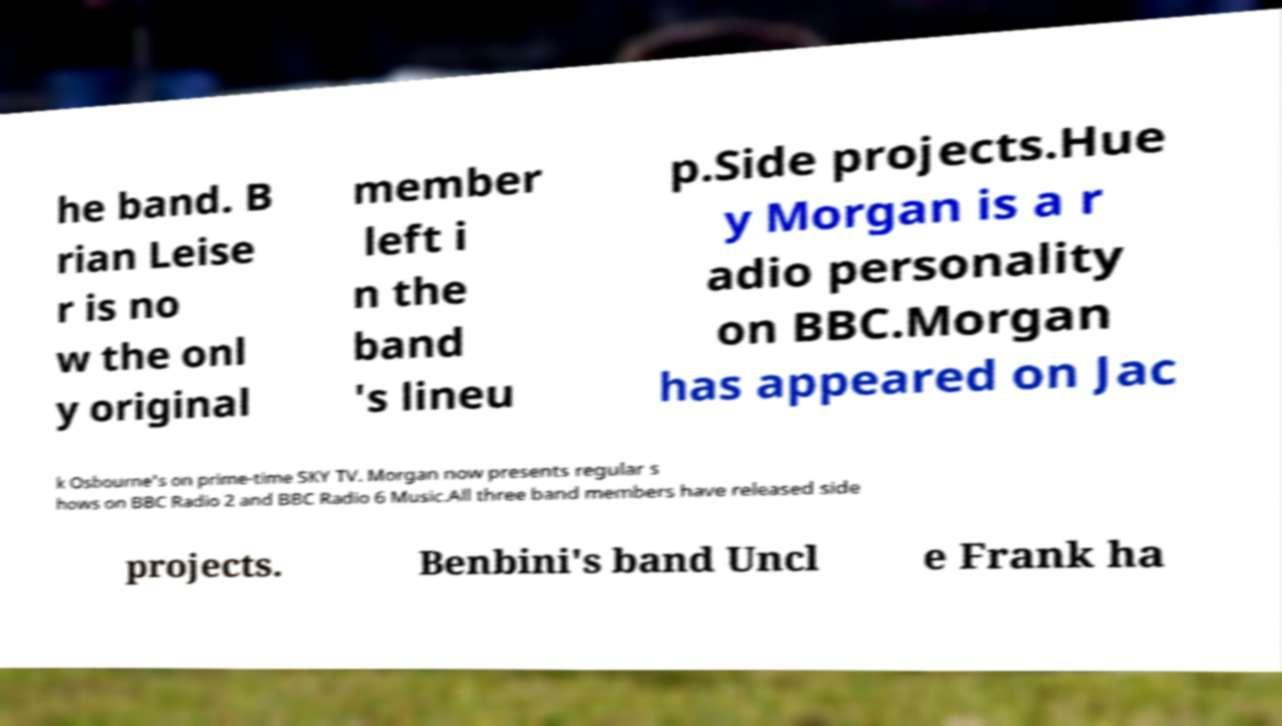What messages or text are displayed in this image? I need them in a readable, typed format. he band. B rian Leise r is no w the onl y original member left i n the band 's lineu p.Side projects.Hue y Morgan is a r adio personality on BBC.Morgan has appeared on Jac k Osbourne's on prime-time SKY TV. Morgan now presents regular s hows on BBC Radio 2 and BBC Radio 6 Music.All three band members have released side projects. Benbini's band Uncl e Frank ha 